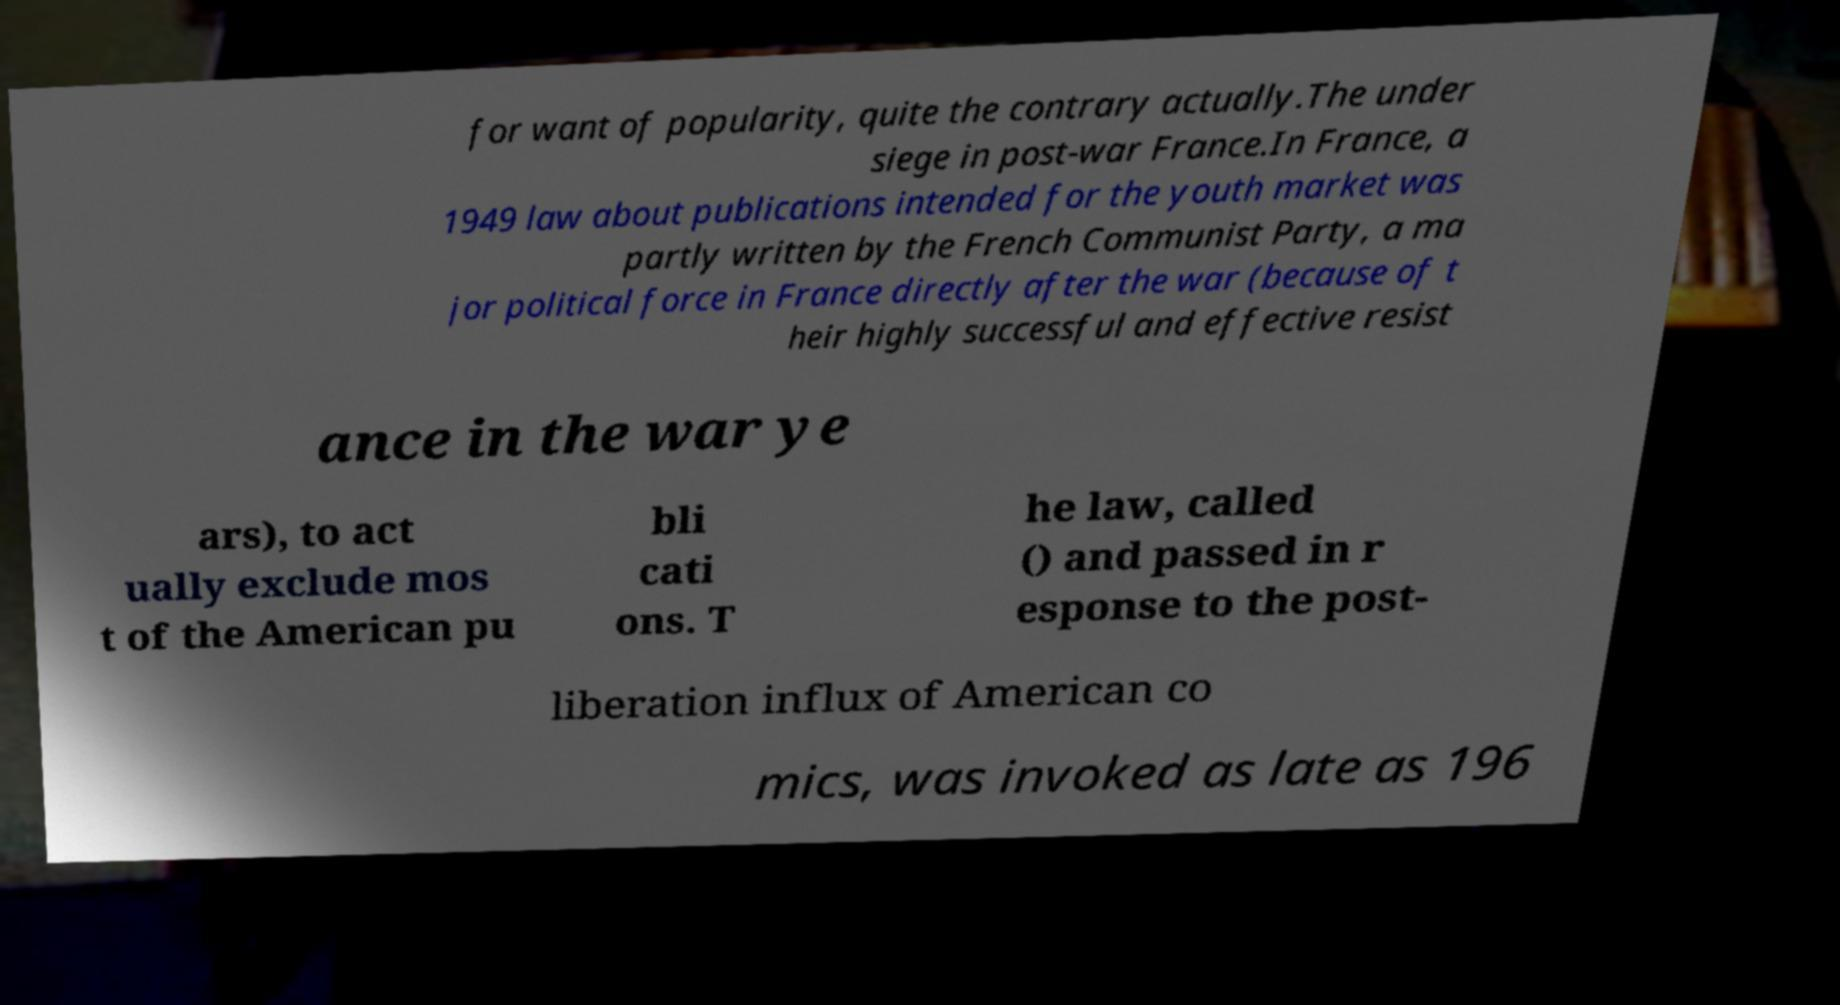Could you extract and type out the text from this image? for want of popularity, quite the contrary actually.The under siege in post-war France.In France, a 1949 law about publications intended for the youth market was partly written by the French Communist Party, a ma jor political force in France directly after the war (because of t heir highly successful and effective resist ance in the war ye ars), to act ually exclude mos t of the American pu bli cati ons. T he law, called () and passed in r esponse to the post- liberation influx of American co mics, was invoked as late as 196 